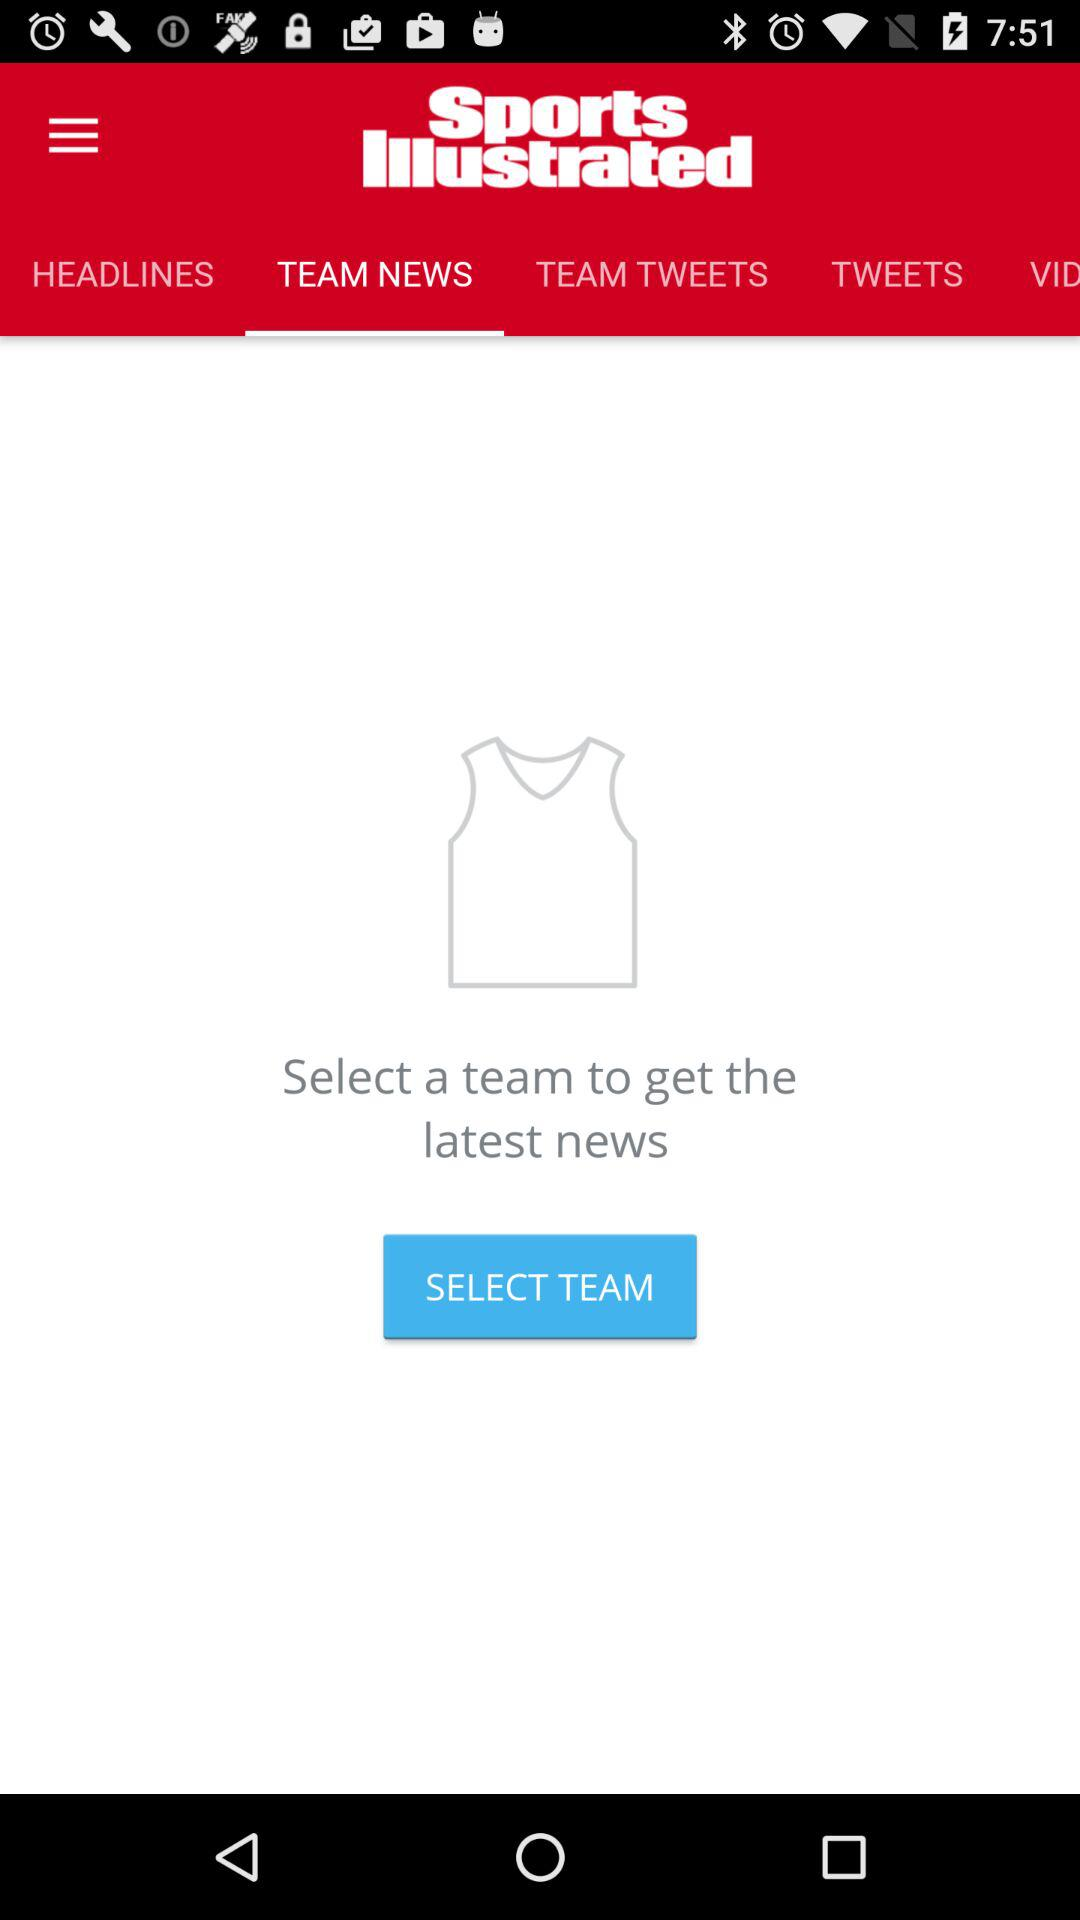How many items are in "TWEETS"?
When the provided information is insufficient, respond with <no answer>. <no answer> 